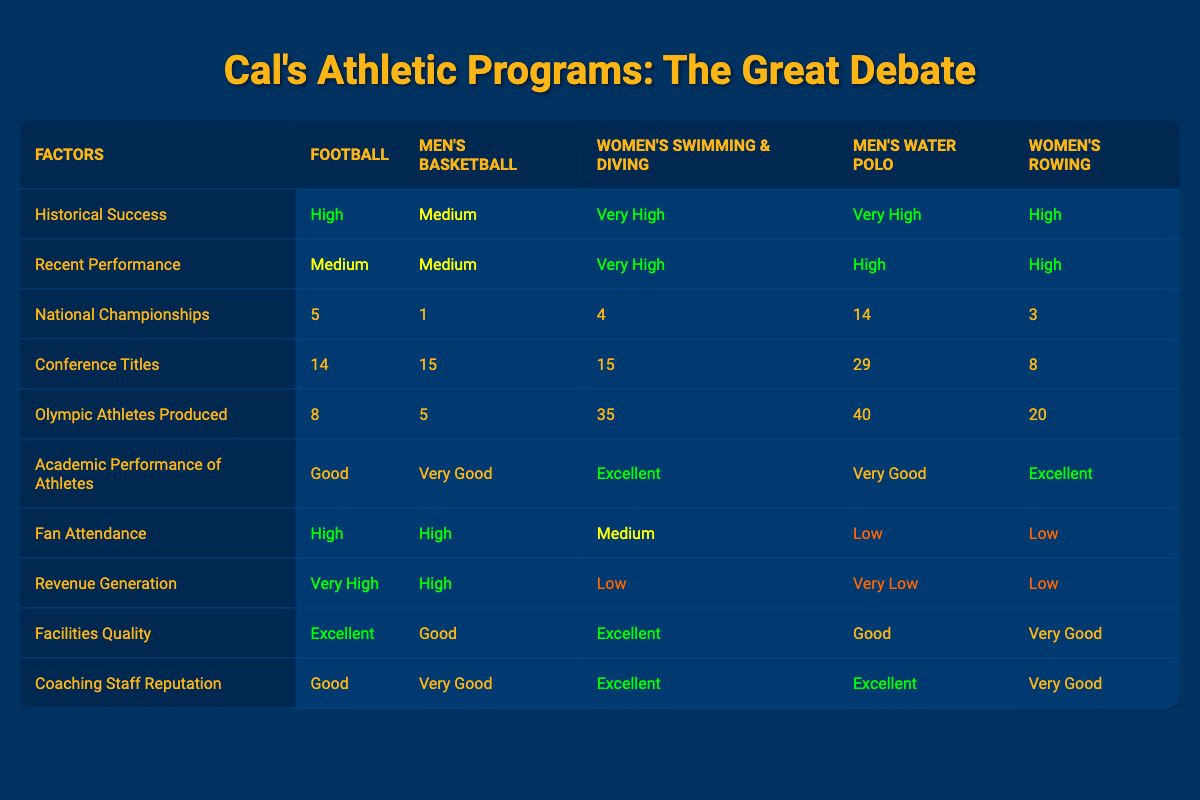What is the historical success rating of Women's Swimming & Diving? The historical success rating for Women's Swimming & Diving is listed in the table as "Very High."
Answer: Very High Which athletic program has the highest number of national championships? The number of national championships for each program shows that Men's Water Polo has 14, which is the highest compared to the other programs.
Answer: Men's Water Polo How many Olympic athletes did Men's Water Polo produce compared to Women's Swimming & Diving? Men's Water Polo produced 40 Olympic athletes while Women's Swimming & Diving produced 35. The difference is 40 - 35 = 5.
Answer: 5 Do all programs have good academic performance of athletes? By reviewing the table, it is clear that Football has "Good," Men's Basketball has "Very Good," while Women's Swimming & Diving, Men's Water Polo, and Women's Rowing have "Excellent." Thus, not all have "Good" academic performance.
Answer: No What is the total number of conference titles won by Football and Women's Rowing combined? From the table, Football has 14 conference titles and Women's Rowing has 8. Adding these together gives 14 + 8 = 22 conference titles in total.
Answer: 22 Which program generates the most revenue? According to the table, Football has a revenue generation labeled as "Very High," which is higher than all other programs listed.
Answer: Football What are the fan attendance levels for Men's Water Polo and Women's Rowing? Men's Water Polo's fan attendance is "Low," while Women's Rowing's is also "Low," indicating both programs do not have high fan attendance.
Answer: Low, Low Which program has the best coaching staff reputation? Comparing the coaching staff reputation across all programs, Women's Swimming & Diving and Men's Water Polo both have "Excellent," making them the top-rated in this respect.
Answer: Women's Swimming & Diving, Men's Water Polo What is the average historical success rating for all programs? The historical success ratings are categorized as "High," "Medium," and "Very High." Translating the ratings to a scale (Very High = 4, High = 3, Medium = 2), the ratings would be: Football (3), Men's Basketball (2), Women's Swimming & Diving (4), Men's Water Polo (4), Women's Rowing (3). The average is (3 + 2 + 4 + 4 + 3) / 5 = 3.2, which equates to an average rating of "High."
Answer: High 